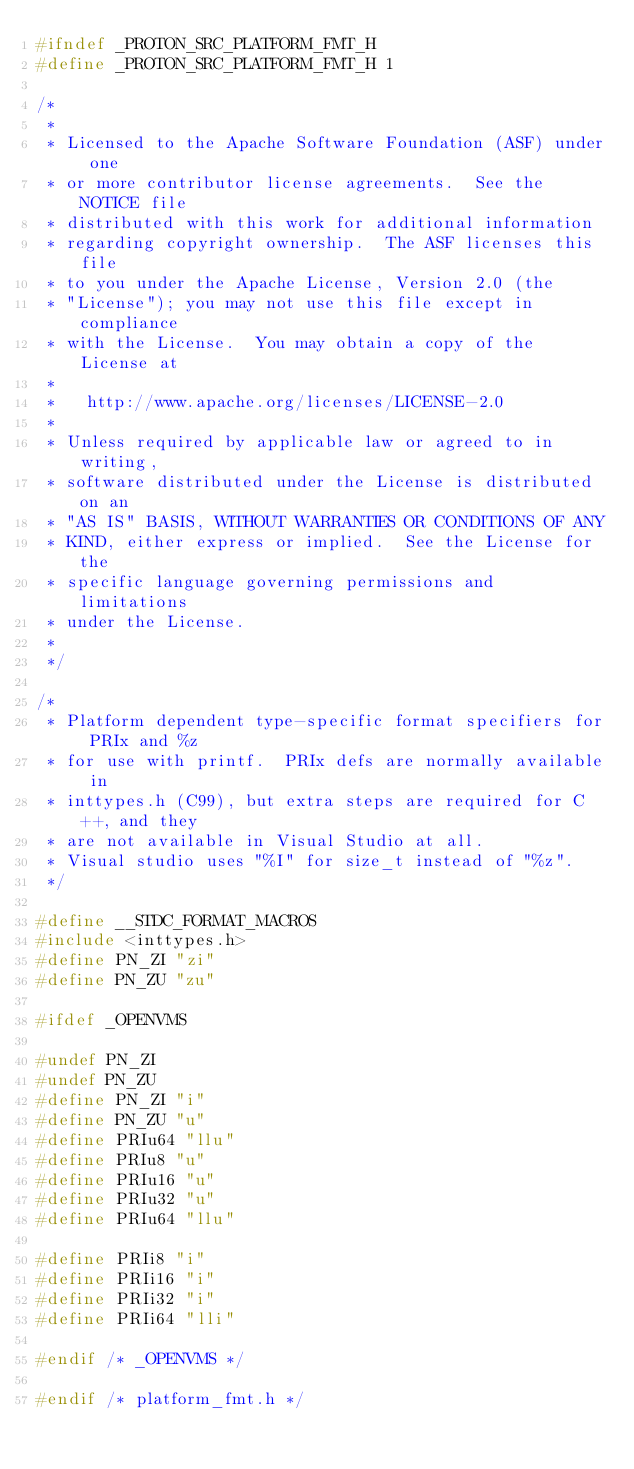Convert code to text. <code><loc_0><loc_0><loc_500><loc_500><_C_>#ifndef _PROTON_SRC_PLATFORM_FMT_H
#define _PROTON_SRC_PLATFORM_FMT_H 1

/*
 *
 * Licensed to the Apache Software Foundation (ASF) under one
 * or more contributor license agreements.  See the NOTICE file
 * distributed with this work for additional information
 * regarding copyright ownership.  The ASF licenses this file
 * to you under the Apache License, Version 2.0 (the
 * "License"); you may not use this file except in compliance
 * with the License.  You may obtain a copy of the License at
 *
 *   http://www.apache.org/licenses/LICENSE-2.0
 *
 * Unless required by applicable law or agreed to in writing,
 * software distributed under the License is distributed on an
 * "AS IS" BASIS, WITHOUT WARRANTIES OR CONDITIONS OF ANY
 * KIND, either express or implied.  See the License for the
 * specific language governing permissions and limitations
 * under the License.
 *
 */

/*
 * Platform dependent type-specific format specifiers for PRIx and %z
 * for use with printf.  PRIx defs are normally available in
 * inttypes.h (C99), but extra steps are required for C++, and they
 * are not available in Visual Studio at all.
 * Visual studio uses "%I" for size_t instead of "%z".
 */

#define __STDC_FORMAT_MACROS
#include <inttypes.h>
#define PN_ZI "zi"
#define PN_ZU "zu"

#ifdef _OPENVMS

#undef PN_ZI
#undef PN_ZU
#define PN_ZI "i"
#define PN_ZU "u"
#define PRIu64 "llu"
#define PRIu8 "u"
#define PRIu16 "u"
#define PRIu32 "u"
#define PRIu64 "llu"

#define PRIi8 "i"
#define PRIi16 "i"
#define PRIi32 "i"
#define PRIi64 "lli"

#endif /* _OPENVMS */

#endif /* platform_fmt.h */
</code> 